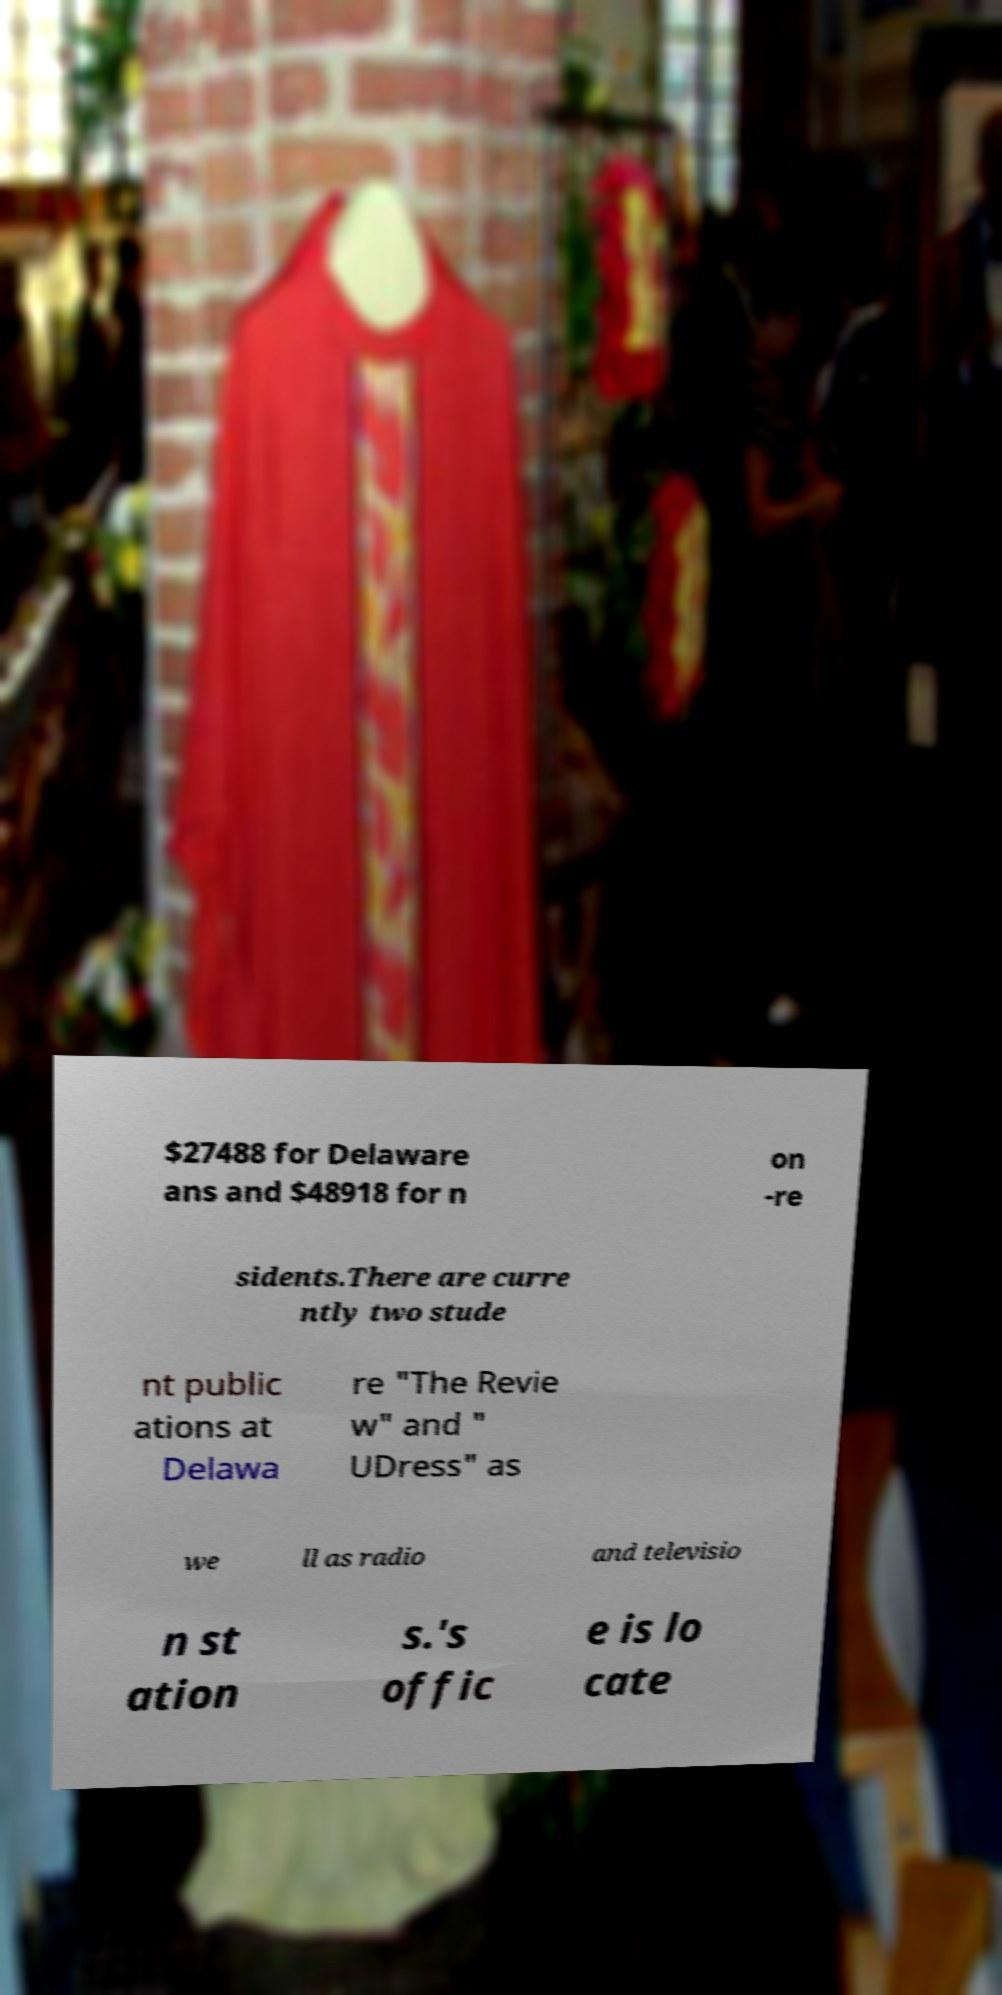What messages or text are displayed in this image? I need them in a readable, typed format. $27488 for Delaware ans and $48918 for n on -re sidents.There are curre ntly two stude nt public ations at Delawa re "The Revie w" and " UDress" as we ll as radio and televisio n st ation s.'s offic e is lo cate 